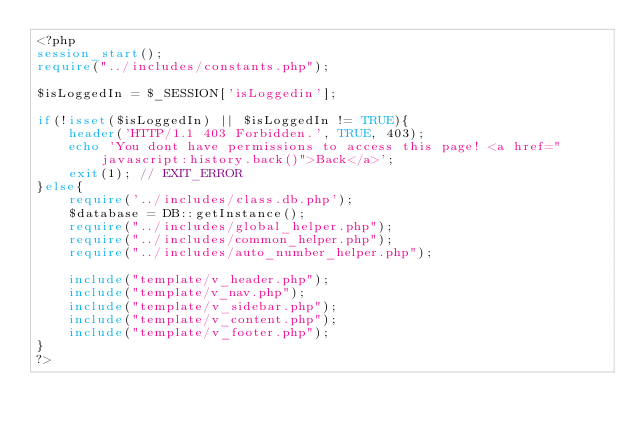<code> <loc_0><loc_0><loc_500><loc_500><_PHP_><?php
session_start();
require("../includes/constants.php");

$isLoggedIn = $_SESSION['isLoggedin'];

if(!isset($isLoggedIn) || $isLoggedIn != TRUE){
    header('HTTP/1.1 403 Forbidden.', TRUE, 403);
    echo 'You dont have permissions to access this page! <a href="javascript:history.back()">Back</a>';
    exit(1); // EXIT_ERROR
}else{
    require('../includes/class.db.php');
    $database = DB::getInstance();
    require("../includes/global_helper.php");
    require("../includes/common_helper.php");
    require("../includes/auto_number_helper.php");

    include("template/v_header.php");
    include("template/v_nav.php");
    include("template/v_sidebar.php");
    include("template/v_content.php");
    include("template/v_footer.php");
}
?></code> 